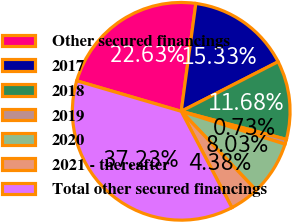Convert chart. <chart><loc_0><loc_0><loc_500><loc_500><pie_chart><fcel>Other secured financings<fcel>2017<fcel>2018<fcel>2019<fcel>2020<fcel>2021 - thereafter<fcel>Total other secured financings<nl><fcel>22.63%<fcel>15.33%<fcel>11.68%<fcel>0.73%<fcel>8.03%<fcel>4.38%<fcel>37.23%<nl></chart> 